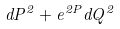Convert formula to latex. <formula><loc_0><loc_0><loc_500><loc_500>d P ^ { 2 } + e ^ { 2 P } d Q ^ { 2 }</formula> 